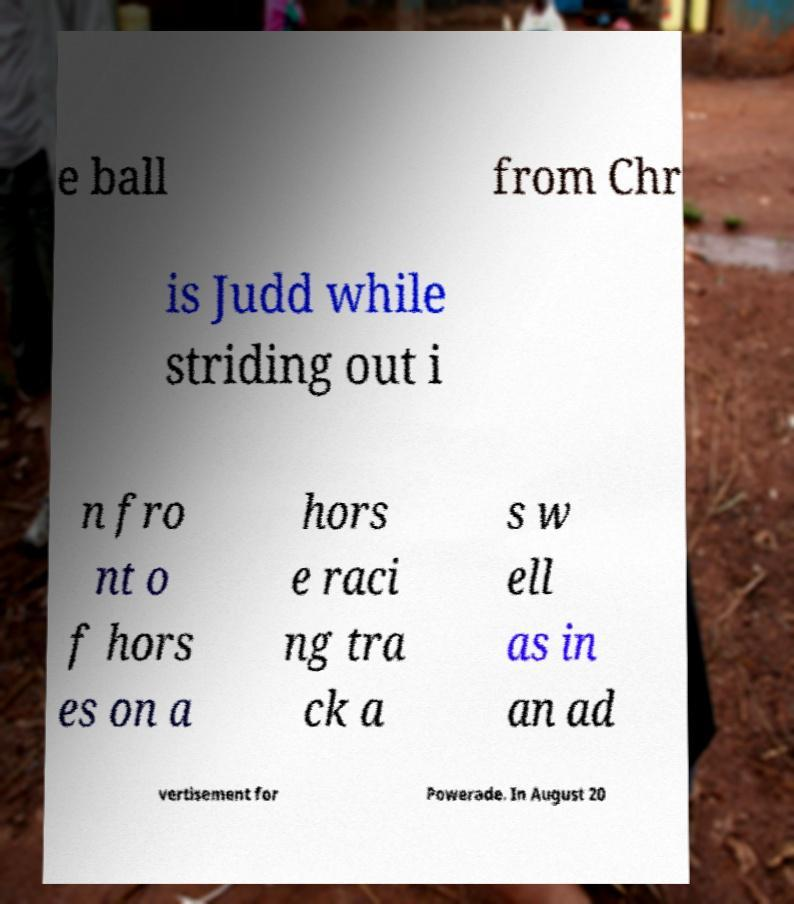For documentation purposes, I need the text within this image transcribed. Could you provide that? e ball from Chr is Judd while striding out i n fro nt o f hors es on a hors e raci ng tra ck a s w ell as in an ad vertisement for Powerade. In August 20 